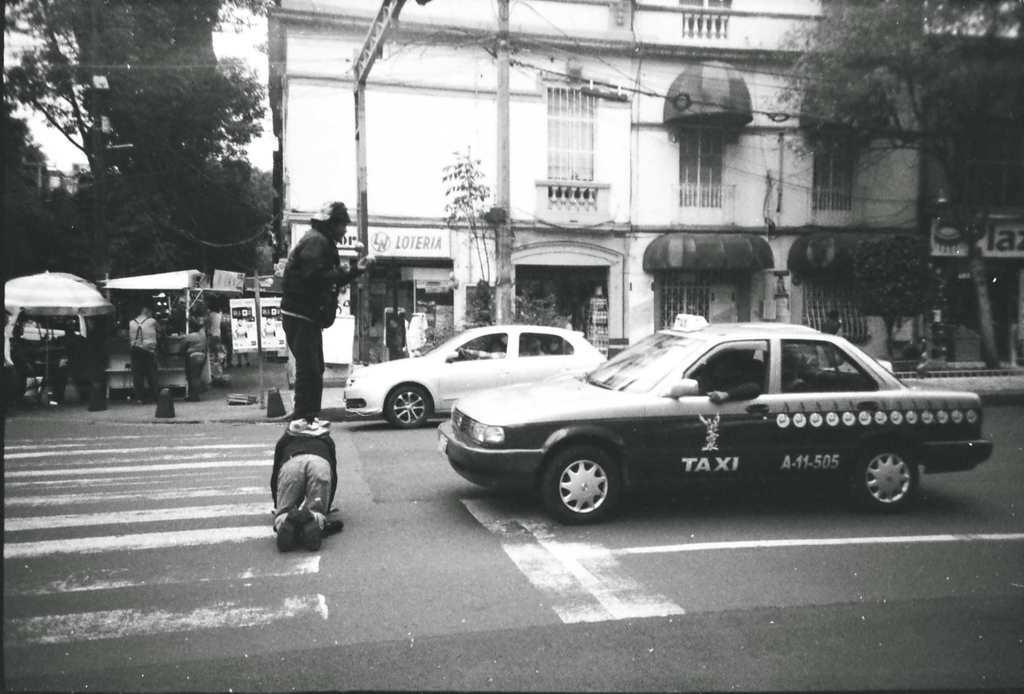<image>
Present a compact description of the photo's key features. A man stands on another person's back in a crosswalk in front of Taxi A-11-505. 